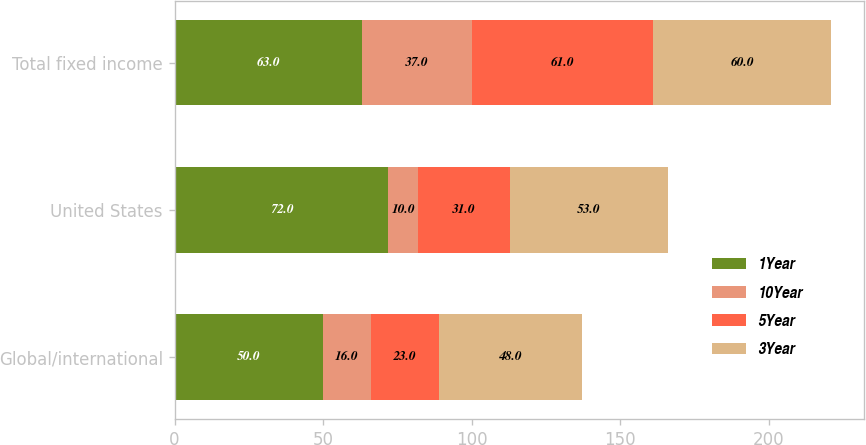<chart> <loc_0><loc_0><loc_500><loc_500><stacked_bar_chart><ecel><fcel>Global/international<fcel>United States<fcel>Total fixed income<nl><fcel>1Year<fcel>50<fcel>72<fcel>63<nl><fcel>10Year<fcel>16<fcel>10<fcel>37<nl><fcel>5Year<fcel>23<fcel>31<fcel>61<nl><fcel>3Year<fcel>48<fcel>53<fcel>60<nl></chart> 